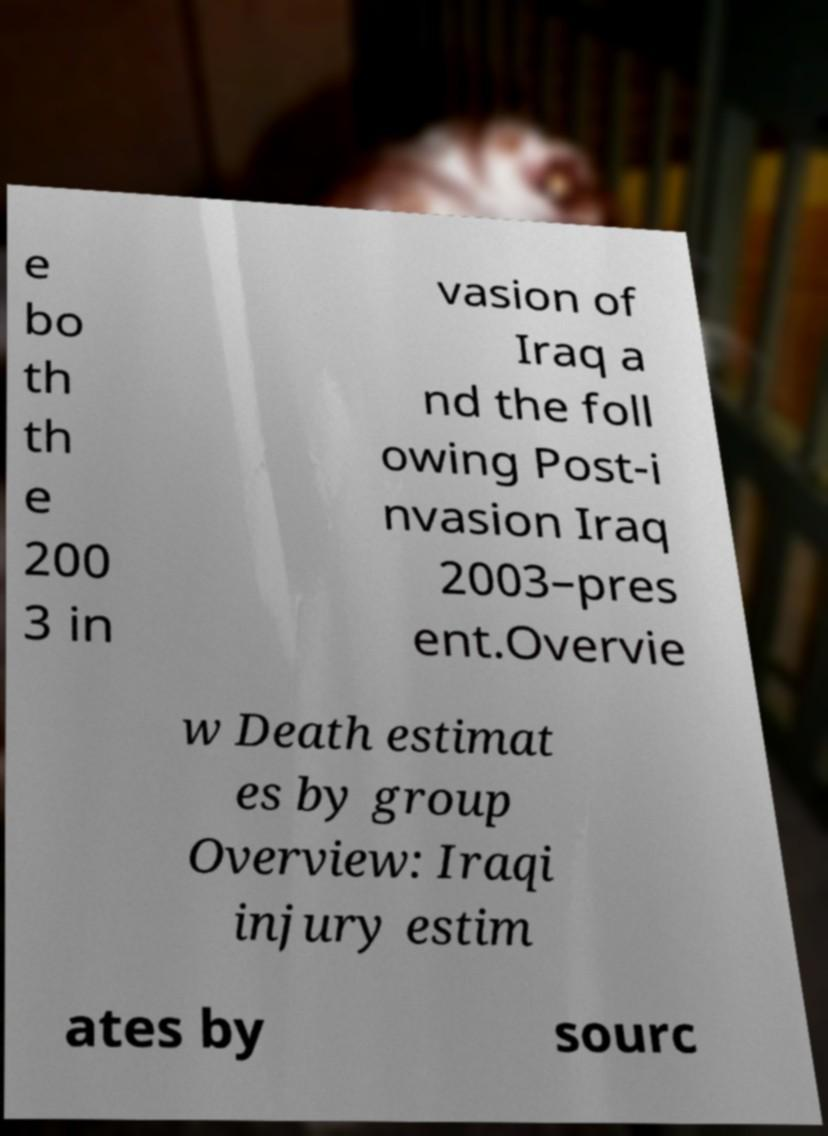What messages or text are displayed in this image? I need them in a readable, typed format. e bo th th e 200 3 in vasion of Iraq a nd the foll owing Post-i nvasion Iraq 2003–pres ent.Overvie w Death estimat es by group Overview: Iraqi injury estim ates by sourc 